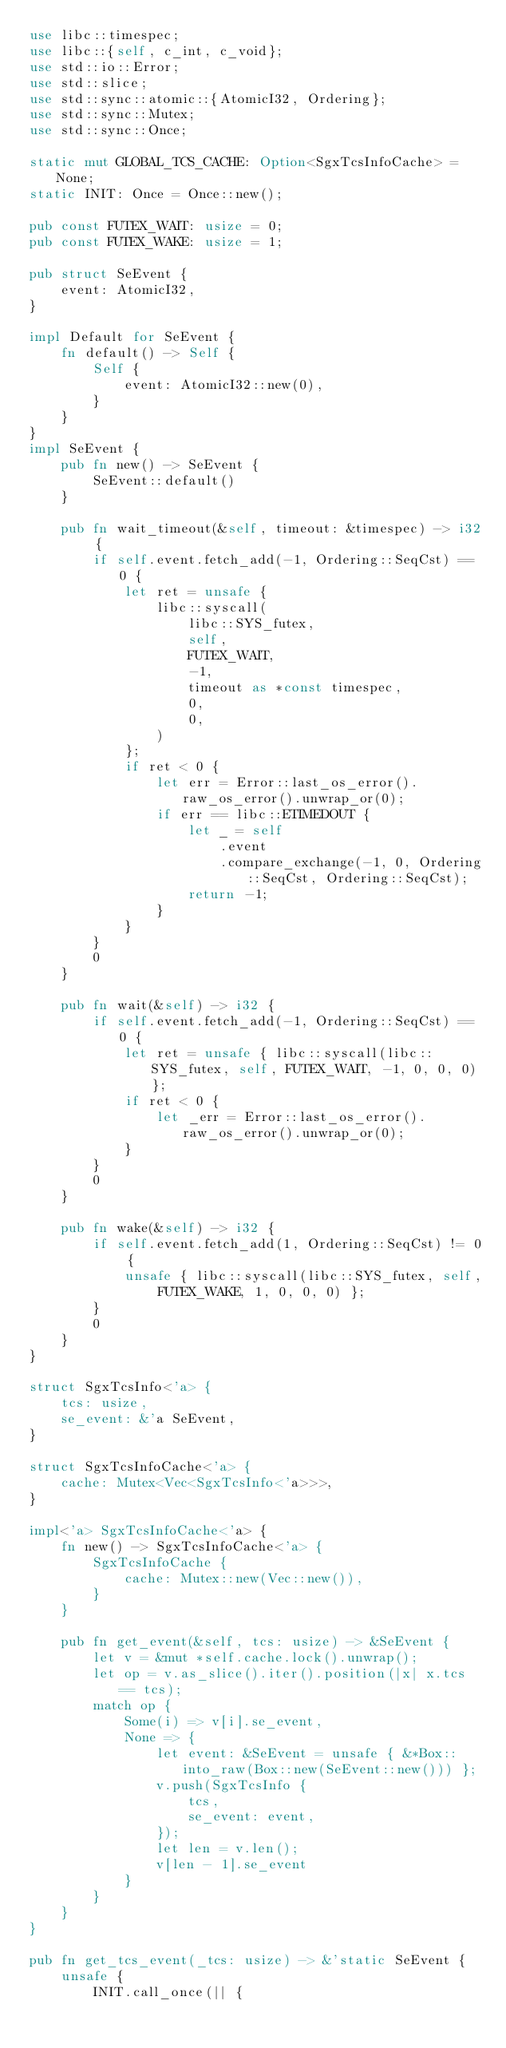<code> <loc_0><loc_0><loc_500><loc_500><_Rust_>use libc::timespec;
use libc::{self, c_int, c_void};
use std::io::Error;
use std::slice;
use std::sync::atomic::{AtomicI32, Ordering};
use std::sync::Mutex;
use std::sync::Once;

static mut GLOBAL_TCS_CACHE: Option<SgxTcsInfoCache> = None;
static INIT: Once = Once::new();

pub const FUTEX_WAIT: usize = 0;
pub const FUTEX_WAKE: usize = 1;

pub struct SeEvent {
    event: AtomicI32,
}

impl Default for SeEvent {
    fn default() -> Self {
        Self {
            event: AtomicI32::new(0),
        }
    }
}
impl SeEvent {
    pub fn new() -> SeEvent {
        SeEvent::default()
    }

    pub fn wait_timeout(&self, timeout: &timespec) -> i32 {
        if self.event.fetch_add(-1, Ordering::SeqCst) == 0 {
            let ret = unsafe {
                libc::syscall(
                    libc::SYS_futex,
                    self,
                    FUTEX_WAIT,
                    -1,
                    timeout as *const timespec,
                    0,
                    0,
                )
            };
            if ret < 0 {
                let err = Error::last_os_error().raw_os_error().unwrap_or(0);
                if err == libc::ETIMEDOUT {
                    let _ = self
                        .event
                        .compare_exchange(-1, 0, Ordering::SeqCst, Ordering::SeqCst);
                    return -1;
                }
            }
        }
        0
    }

    pub fn wait(&self) -> i32 {
        if self.event.fetch_add(-1, Ordering::SeqCst) == 0 {
            let ret = unsafe { libc::syscall(libc::SYS_futex, self, FUTEX_WAIT, -1, 0, 0, 0) };
            if ret < 0 {
                let _err = Error::last_os_error().raw_os_error().unwrap_or(0);
            }
        }
        0
    }

    pub fn wake(&self) -> i32 {
        if self.event.fetch_add(1, Ordering::SeqCst) != 0 {
            unsafe { libc::syscall(libc::SYS_futex, self, FUTEX_WAKE, 1, 0, 0, 0) };
        }
        0
    }
}

struct SgxTcsInfo<'a> {
    tcs: usize,
    se_event: &'a SeEvent,
}

struct SgxTcsInfoCache<'a> {
    cache: Mutex<Vec<SgxTcsInfo<'a>>>,
}

impl<'a> SgxTcsInfoCache<'a> {
    fn new() -> SgxTcsInfoCache<'a> {
        SgxTcsInfoCache {
            cache: Mutex::new(Vec::new()),
        }
    }

    pub fn get_event(&self, tcs: usize) -> &SeEvent {
        let v = &mut *self.cache.lock().unwrap();
        let op = v.as_slice().iter().position(|x| x.tcs == tcs);
        match op {
            Some(i) => v[i].se_event,
            None => {
                let event: &SeEvent = unsafe { &*Box::into_raw(Box::new(SeEvent::new())) };
                v.push(SgxTcsInfo {
                    tcs,
                    se_event: event,
                });
                let len = v.len();
                v[len - 1].se_event
            }
        }
    }
}

pub fn get_tcs_event(_tcs: usize) -> &'static SeEvent {
    unsafe {
        INIT.call_once(|| {</code> 